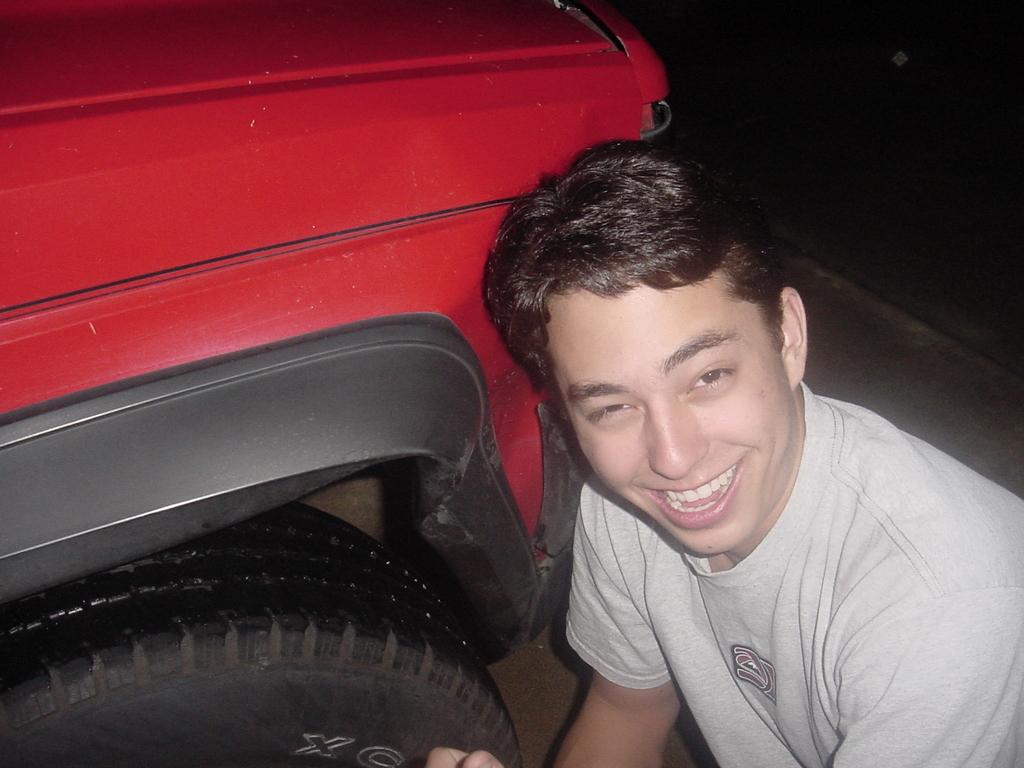What is located on the right side of the image? There is a man on the right side of the image. What is the man doing in the image? The man is smiling in the image. What type of clothing is the man wearing? The man is wearing a t-shirt in the image. What can be seen on the left side of the image? There is a red vehicle on the left side of the image. How many balls are being used in the hot tub in the image? There is no hot tub or balls present in the image. 